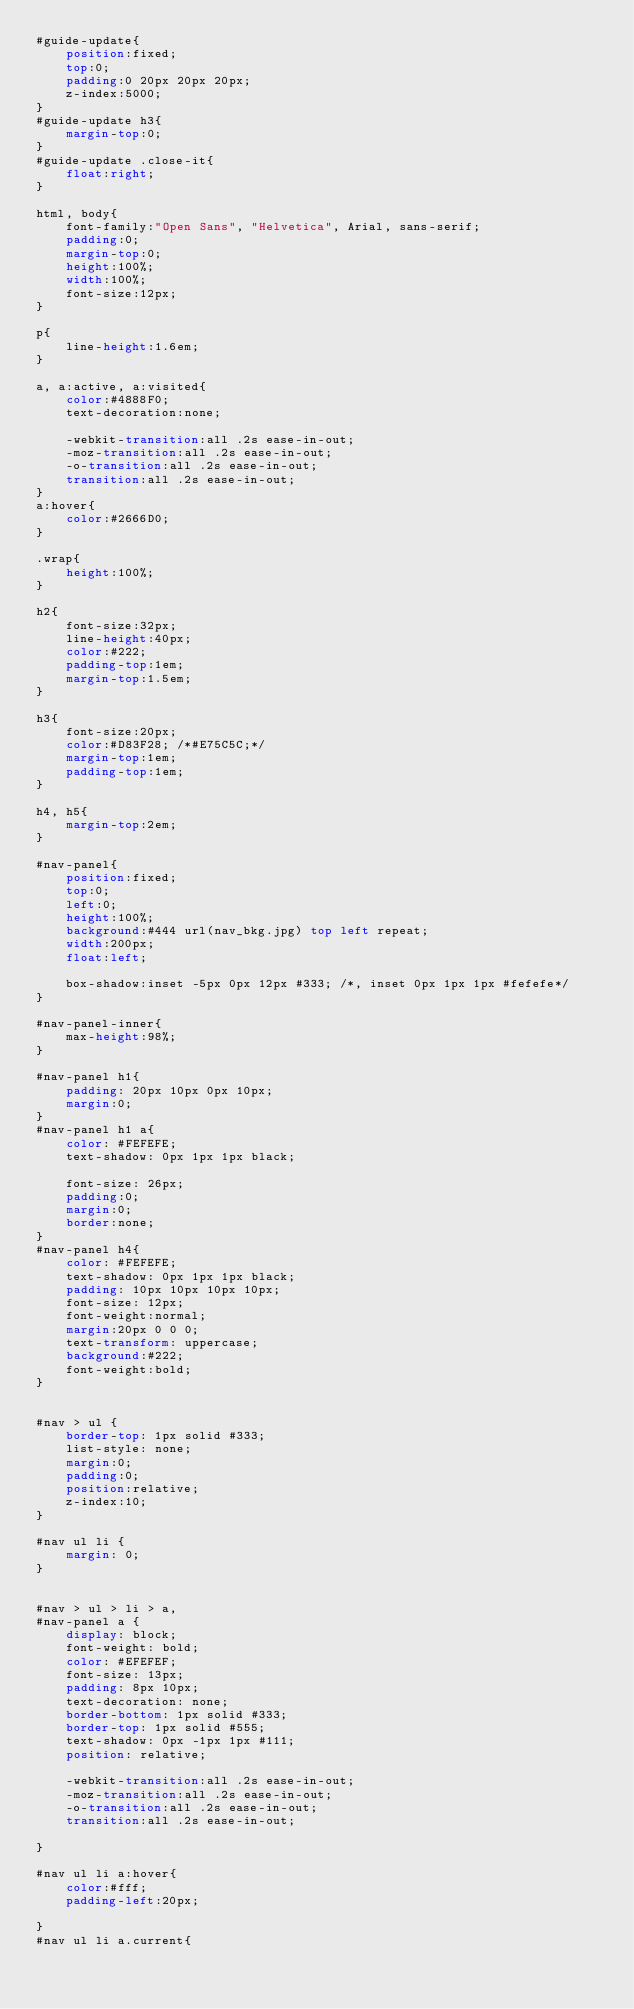Convert code to text. <code><loc_0><loc_0><loc_500><loc_500><_CSS_>#guide-update{
	position:fixed;
	top:0;
	padding:0 20px 20px 20px;
	z-index:5000;
}
#guide-update h3{
	margin-top:0;
}
#guide-update .close-it{
	float:right;
}

html, body{
	font-family:"Open Sans", "Helvetica", Arial, sans-serif;
	padding:0;
	margin-top:0;
	height:100%;
	width:100%;
	font-size:12px;
}

p{
	line-height:1.6em;
}

a, a:active, a:visited{
	color:#4888F0;
	text-decoration:none;
	
	-webkit-transition:all .2s ease-in-out;
	-moz-transition:all .2s ease-in-out;
	-o-transition:all .2s ease-in-out;
	transition:all .2s ease-in-out;
}
a:hover{
	color:#2666D0;
}

.wrap{
	height:100%;
}

h2{
	font-size:32px;
	line-height:40px;
	color:#222;
	padding-top:1em;
	margin-top:1.5em;
}

h3{
	font-size:20px;
	color:#D83F28; /*#E75C5C;*/
	margin-top:1em;
	padding-top:1em;
}

h4, h5{
	margin-top:2em;
}

#nav-panel{
	position:fixed;
	top:0;
	left:0;
	height:100%;
	background:#444 url(nav_bkg.jpg) top left repeat;
	width:200px;
	float:left;
	
	box-shadow:inset -5px 0px 12px #333; /*, inset 0px 1px 1px #fefefe*/
}

#nav-panel-inner{
	max-height:98%;
}

#nav-panel h1{
	padding: 20px 10px 0px 10px;
	margin:0;
}
#nav-panel h1 a{
	color: #FEFEFE;
	text-shadow: 0px 1px 1px black;
	
	font-size: 26px;	
	padding:0;
	margin:0;
	border:none;
}
#nav-panel h4{
	color: #FEFEFE;
	text-shadow: 0px 1px 1px black;
	padding: 10px 10px 10px 10px;
	font-size: 12px;
	font-weight:normal;	
	margin:20px 0 0 0;
	text-transform: uppercase;
	background:#222;
	font-weight:bold;
}


#nav > ul {
	border-top: 1px solid #333;
	list-style: none;
	margin:0;
	padding:0;
	position:relative;
	z-index:10;
}

#nav ul li {
	margin: 0;
}


#nav > ul > li > a,
#nav-panel a {
	display: block;
	font-weight: bold;
	color: #EFEFEF;
	font-size: 13px;
	padding: 8px 10px;
	text-decoration: none;
	border-bottom: 1px solid #333;
	border-top: 1px solid #555;
	text-shadow: 0px -1px 1px #111;
	position: relative;
	
	-webkit-transition:all .2s ease-in-out;
	-moz-transition:all .2s ease-in-out;
	-o-transition:all .2s ease-in-out;
	transition:all .2s ease-in-out;
	
}

#nav ul li a:hover{
	color:#fff;
	padding-left:20px;
	
}
#nav ul li a.current{</code> 